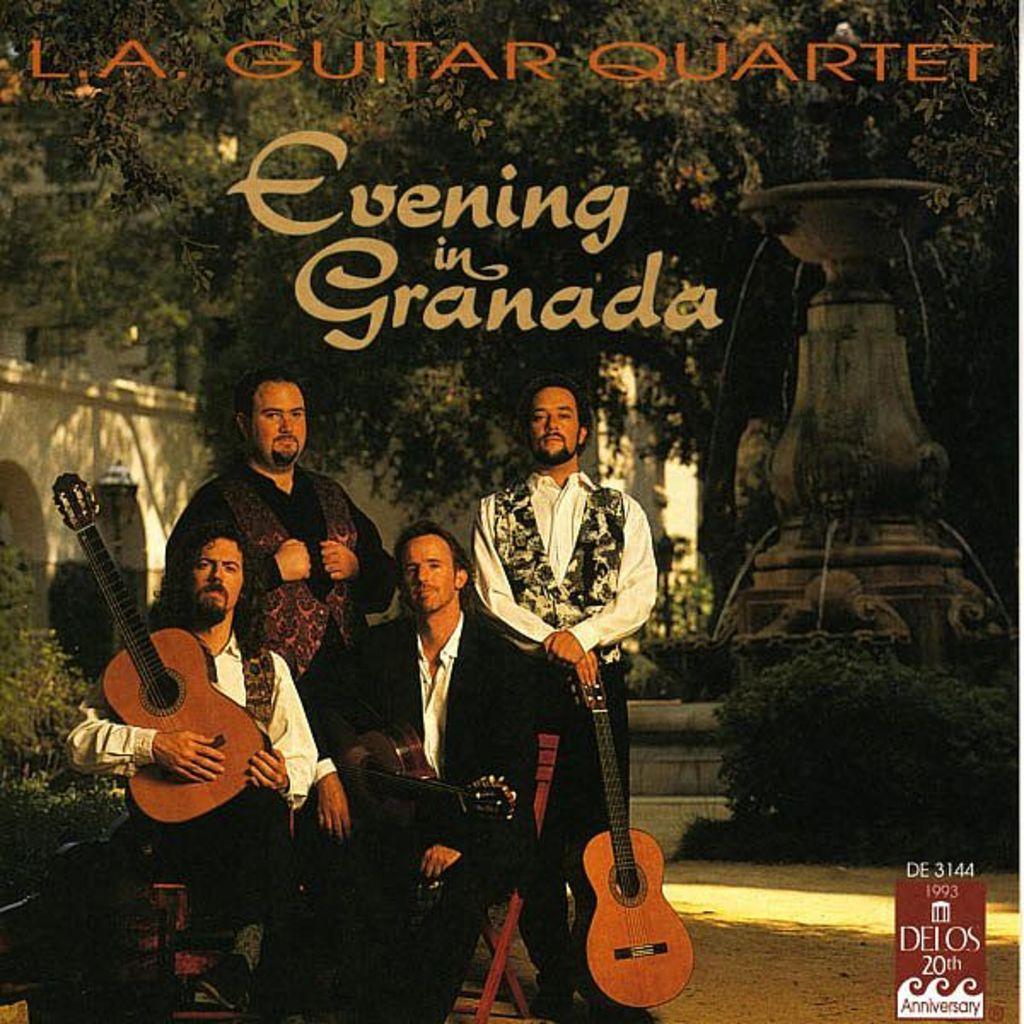In one or two sentences, can you explain what this image depicts? This are 4 musicians giving stills. This 2 persons are sitting on a chair and holds a guitar. This are trees. This is a statue. These are plants. Far there is a building. 